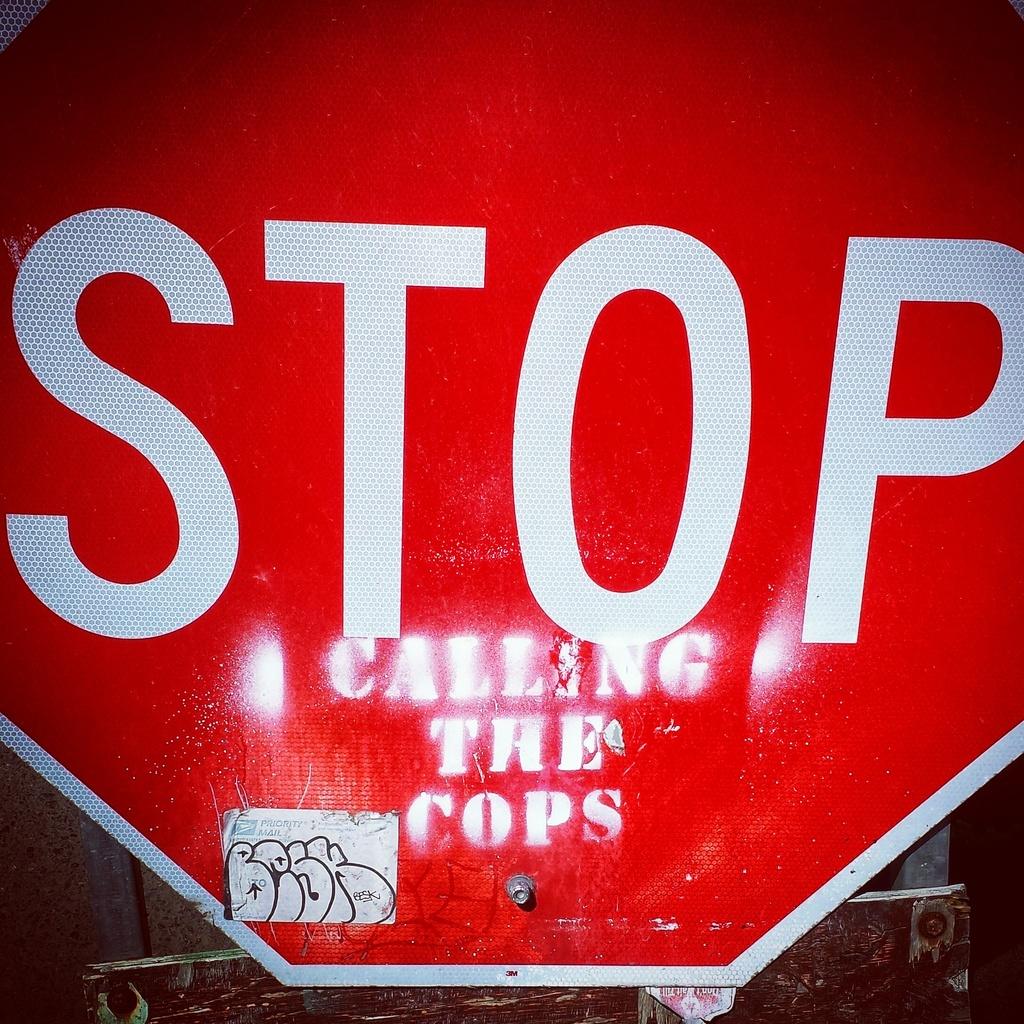What does the sign say to do?
Make the answer very short. Stop calling the cops. 